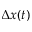Convert formula to latex. <formula><loc_0><loc_0><loc_500><loc_500>\Delta x ( t )</formula> 